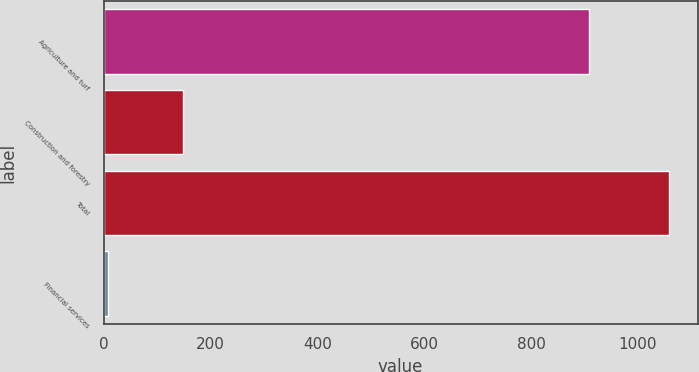Convert chart. <chart><loc_0><loc_0><loc_500><loc_500><bar_chart><fcel>Agriculture and turf<fcel>Construction and forestry<fcel>Total<fcel>Financial services<nl><fcel>909<fcel>148<fcel>1059<fcel>8<nl></chart> 